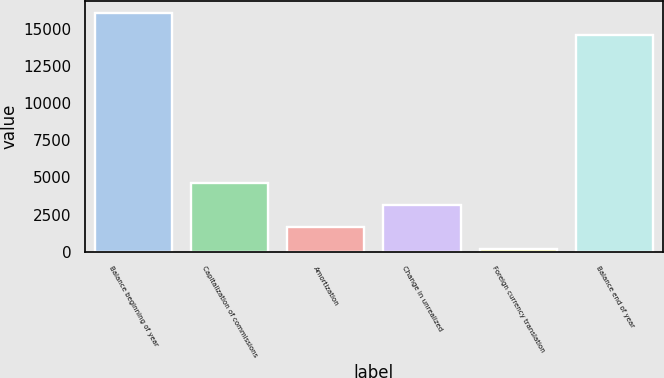Convert chart. <chart><loc_0><loc_0><loc_500><loc_500><bar_chart><fcel>Balance beginning of year<fcel>Capitalization of commissions<fcel>Amortization<fcel>Change in unrealized<fcel>Foreign currency translation<fcel>Balance end of year<nl><fcel>16073.1<fcel>4660.3<fcel>1670.1<fcel>3165.2<fcel>175<fcel>14578<nl></chart> 